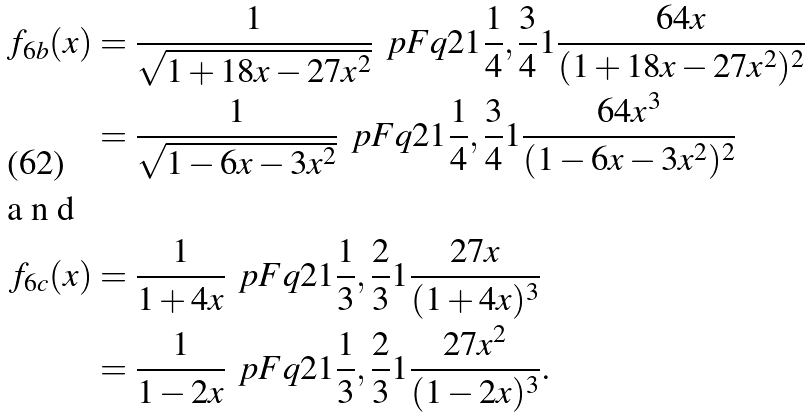Convert formula to latex. <formula><loc_0><loc_0><loc_500><loc_500>f _ { 6 b } ( x ) & = \frac { 1 } { \sqrt { 1 + 1 8 x - 2 7 x ^ { 2 } } } \, \ p F q { 2 } { 1 } { \frac { 1 } { 4 } , \frac { 3 } { 4 } } { 1 } { \frac { 6 4 x } { ( 1 + 1 8 x - 2 7 x ^ { 2 } ) ^ { 2 } } } \\ & = \frac { 1 } { \sqrt { 1 - 6 x - 3 x ^ { 2 } } } \, \ p F q { 2 } { 1 } { \frac { 1 } { 4 } , \frac { 3 } { 4 } } { 1 } { \frac { 6 4 x ^ { 3 } } { ( 1 - 6 x - 3 x ^ { 2 } ) ^ { 2 } } } \intertext { a n d } f _ { 6 c } ( x ) & = \frac { 1 } { 1 + 4 x } \, \ p F q { 2 } { 1 } { \frac { 1 } { 3 } , \frac { 2 } { 3 } } { 1 } { \frac { 2 7 x } { ( 1 + 4 x ) ^ { 3 } } } \\ & = \frac { 1 } { 1 - 2 x } \, \ p F q { 2 } { 1 } { \frac { 1 } { 3 } , \frac { 2 } { 3 } } { 1 } { \frac { 2 7 x ^ { 2 } } { ( 1 - 2 x ) ^ { 3 } } } .</formula> 